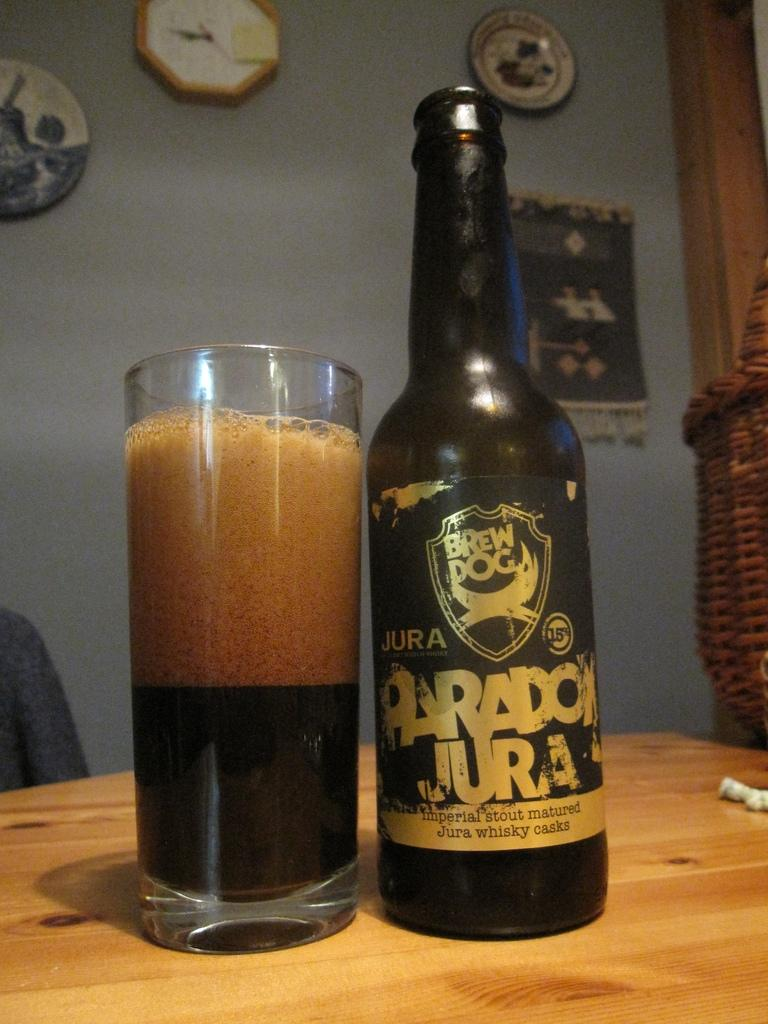<image>
Summarize the visual content of the image. a bottle of paradox jura beer next to a glass 